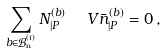Convert formula to latex. <formula><loc_0><loc_0><loc_500><loc_500>\sum _ { b \in \mathcal { B } ^ { ( i ) } _ { \text {n} } } N ^ { ( b ) } _ { | P } \ \ V { \bar { n } } _ { | P } ^ { ( b ) } = 0 \, ,</formula> 